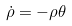Convert formula to latex. <formula><loc_0><loc_0><loc_500><loc_500>\dot { \rho } = - \rho \theta</formula> 